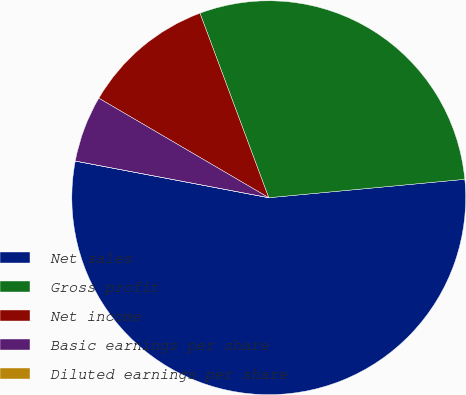<chart> <loc_0><loc_0><loc_500><loc_500><pie_chart><fcel>Net sales<fcel>Gross profit<fcel>Net income<fcel>Basic earnings per share<fcel>Diluted earnings per share<nl><fcel>54.47%<fcel>29.19%<fcel>10.89%<fcel>5.45%<fcel>0.0%<nl></chart> 